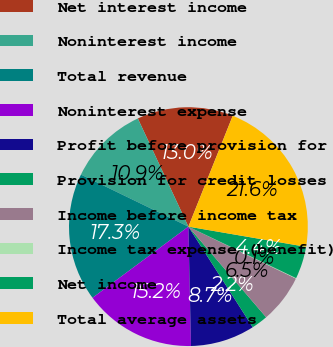Convert chart to OTSL. <chart><loc_0><loc_0><loc_500><loc_500><pie_chart><fcel>Net interest income<fcel>Noninterest income<fcel>Total revenue<fcel>Noninterest expense<fcel>Profit before provision for<fcel>Provision for credit losses<fcel>Income before income tax<fcel>Income tax expense (benefit)<fcel>Net income<fcel>Total average assets<nl><fcel>13.02%<fcel>10.86%<fcel>17.34%<fcel>15.18%<fcel>8.71%<fcel>2.23%<fcel>6.55%<fcel>0.07%<fcel>4.39%<fcel>21.65%<nl></chart> 